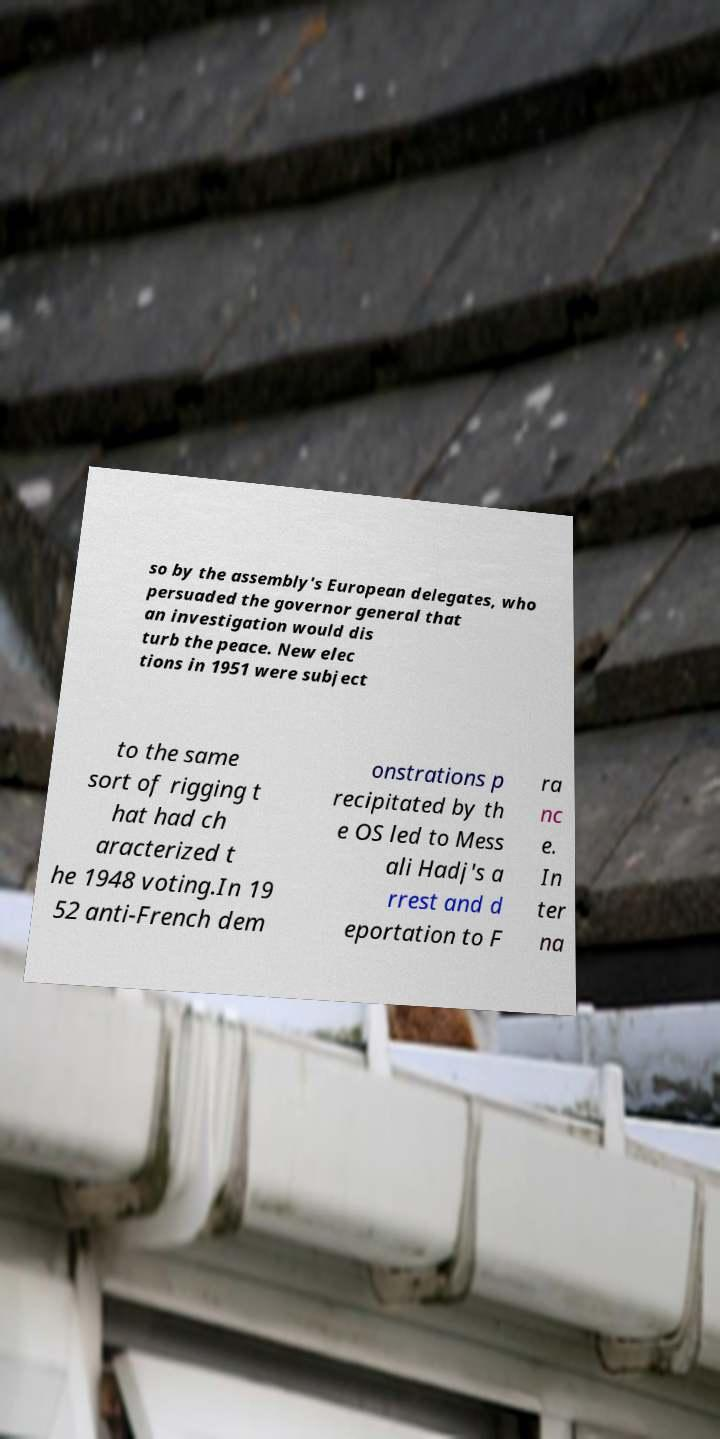Could you assist in decoding the text presented in this image and type it out clearly? so by the assembly's European delegates, who persuaded the governor general that an investigation would dis turb the peace. New elec tions in 1951 were subject to the same sort of rigging t hat had ch aracterized t he 1948 voting.In 19 52 anti-French dem onstrations p recipitated by th e OS led to Mess ali Hadj's a rrest and d eportation to F ra nc e. In ter na 